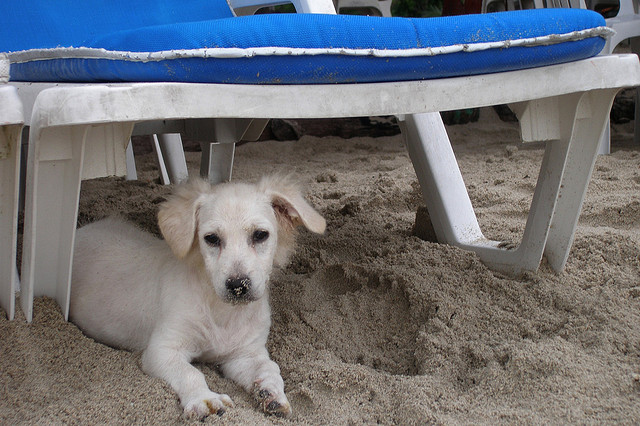<image>How aggressive can these dogs get? The level of aggression in these dogs is ambiguous. It varies from dog to dog and depends on their training and temperament. What kind of dog is here? I don't know what kind of dog is here. It can be a puppy, harrier, mutt, shepard, retriever, labrador or terrier. How aggressive can these dogs get? I don't know how aggressive these dogs can get. It seems that they are not very aggressive. What kind of dog is here? It is not clear what kind of dog is in the image. It can be a puppy, harrier, mutt, shepard, retriever, labrador, or terrier. 